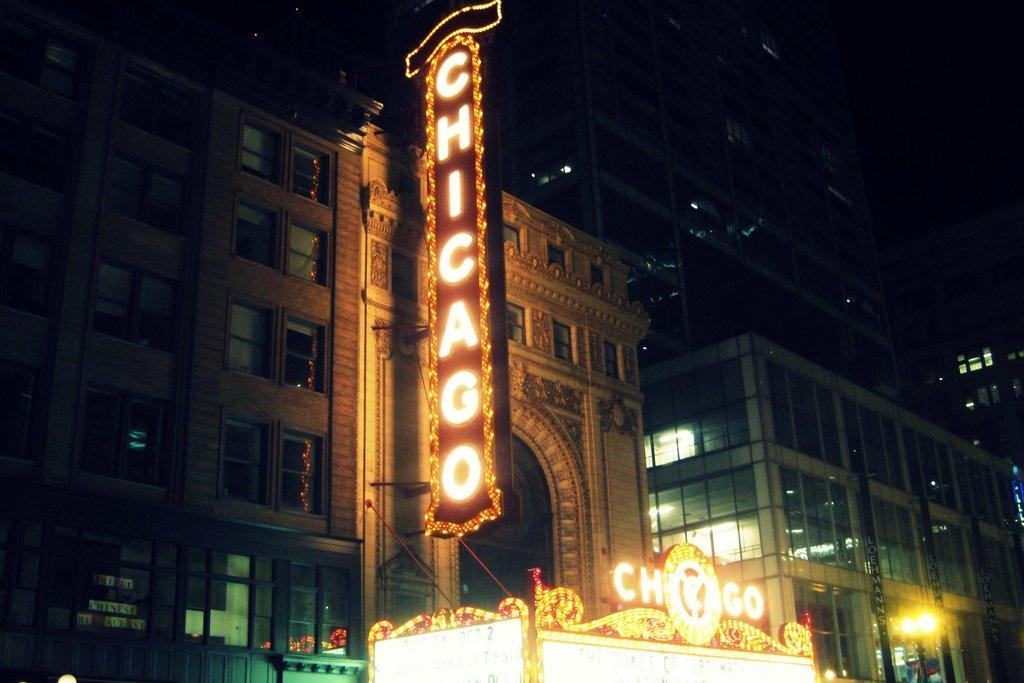What is the main object in the image? There is a board in the image. What is the board related to? The board is related to a building. What can be seen to the right in the image? There are lights visible to the right in the image. What is the color of the background in the image? The background of the image is black. Can you see any bats flying around in the image? There are no bats visible in the image. What type of vacation is being advertised on the board in the image? The board is related to a building, not a vacation, so there is no information about a vacation in the image. 